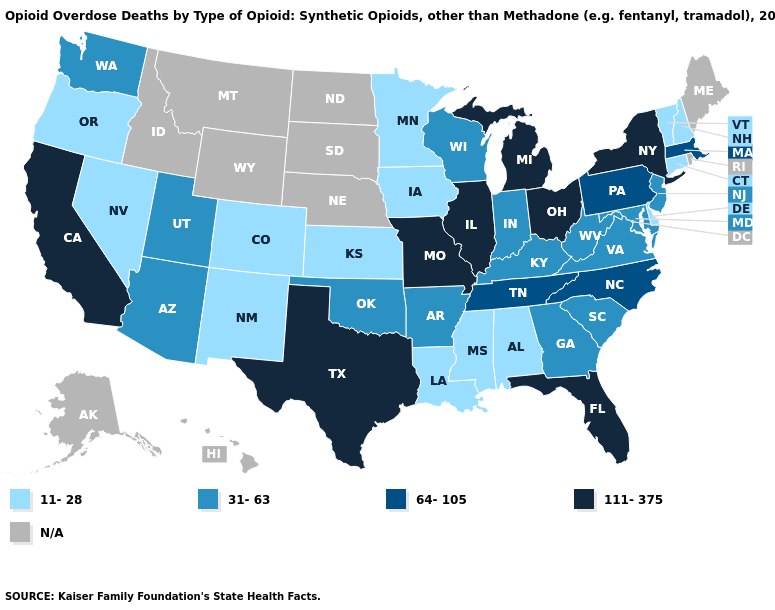Does Iowa have the highest value in the USA?
Short answer required. No. Which states hav the highest value in the Northeast?
Write a very short answer. New York. Which states hav the highest value in the South?
Keep it brief. Florida, Texas. Name the states that have a value in the range 111-375?
Answer briefly. California, Florida, Illinois, Michigan, Missouri, New York, Ohio, Texas. What is the lowest value in the South?
Be succinct. 11-28. What is the value of Illinois?
Give a very brief answer. 111-375. Among the states that border Tennessee , does Missouri have the highest value?
Quick response, please. Yes. How many symbols are there in the legend?
Concise answer only. 5. Among the states that border South Carolina , does Georgia have the highest value?
Write a very short answer. No. Is the legend a continuous bar?
Short answer required. No. What is the value of Maryland?
Quick response, please. 31-63. What is the lowest value in the USA?
Short answer required. 11-28. What is the value of Nebraska?
Be succinct. N/A. Does Vermont have the lowest value in the USA?
Short answer required. Yes. 